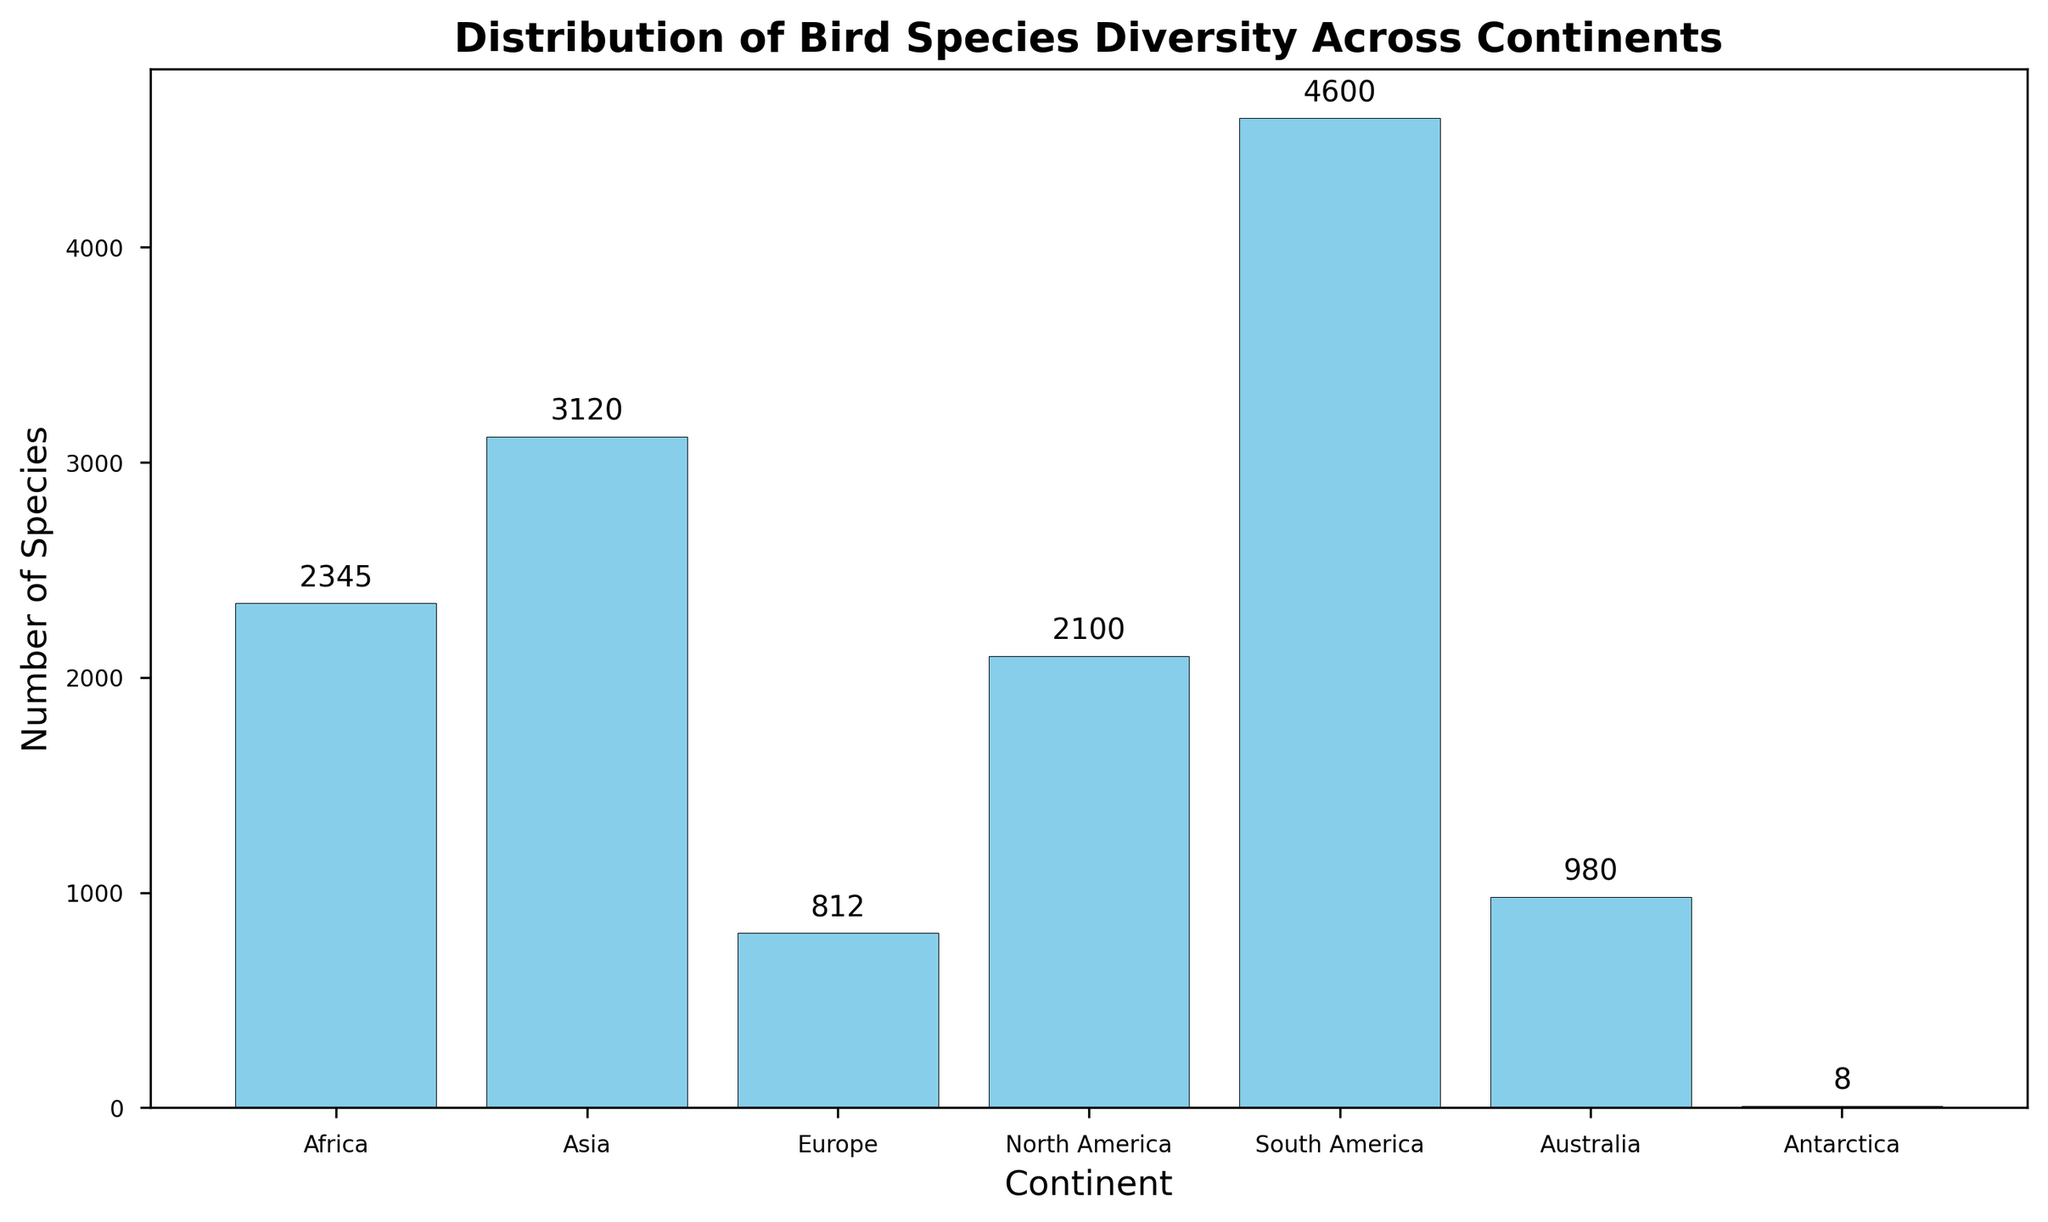What's the continent with the highest bird species diversity? The y-axis represents the number of species, and the highest bar corresponds to South America.
Answer: South America Which continents have a bird species diversity greater than 2000? The figure shows bars representing species counts. Both Asia, Africa, and North America have bars that exceed 2000 species.
Answer: Asia, Africa, North America How many more bird species are there in South America compared to Antarctica? The bar for South America is at 4600, and Antarctica is at 8. The difference is calculated as 4600 - 8.
Answer: 4592 What is the average bird species count across all continents? Sum all species counts (2345 + 3120 + 812 + 2100 + 4600 + 980 + 8) and then divide by the number of continents (7).
Answer: 1995 What's the total bird species diversity in the northern hemisphere? The northern hemisphere consists of Europe, North America, and a part of Asia. Add the species counts for Europe (812), North America (2100), and Asia (3120).
Answer: 6032 Which two continents have the closest bird species counts? Europe and Australia have species counts of 812 and 980, respectively. The difference is 980 - 812 = 168.
Answer: Europe, Australia What is the difference in bird species diversity between the continent with the second highest count and the third highest count? The second highest is Asia (3120), and the third highest is Africa (2345). The difference is 3120 - 2345.
Answer: 775 How does the bird species diversity in Australia compare to Europe? The bar heights for Australia and Europe represent 980 and 812 species, respectively. Australia has more species.
Answer: More What's the sum of bird species in continents with less than 1000 species? Australia and Antarctica have less than 1000 species. Sum up their counts: 980 + 8.
Answer: 988 